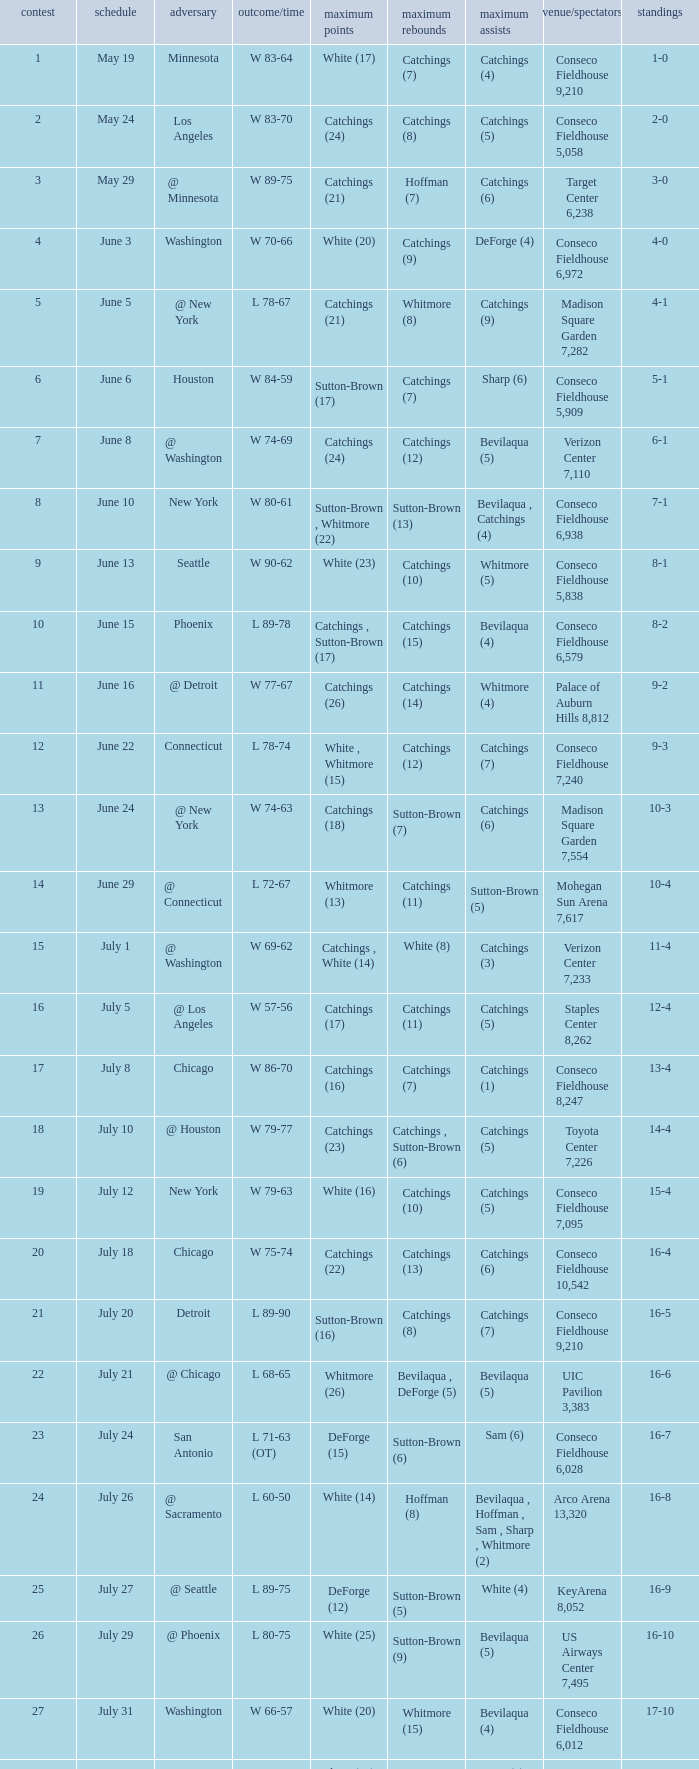Name the total number of opponent of record 9-2 1.0. Write the full table. {'header': ['contest', 'schedule', 'adversary', 'outcome/time', 'maximum points', 'maximum rebounds', 'maximum assists', 'venue/spectators', 'standings'], 'rows': [['1', 'May 19', 'Minnesota', 'W 83-64', 'White (17)', 'Catchings (7)', 'Catchings (4)', 'Conseco Fieldhouse 9,210', '1-0'], ['2', 'May 24', 'Los Angeles', 'W 83-70', 'Catchings (24)', 'Catchings (8)', 'Catchings (5)', 'Conseco Fieldhouse 5,058', '2-0'], ['3', 'May 29', '@ Minnesota', 'W 89-75', 'Catchings (21)', 'Hoffman (7)', 'Catchings (6)', 'Target Center 6,238', '3-0'], ['4', 'June 3', 'Washington', 'W 70-66', 'White (20)', 'Catchings (9)', 'DeForge (4)', 'Conseco Fieldhouse 6,972', '4-0'], ['5', 'June 5', '@ New York', 'L 78-67', 'Catchings (21)', 'Whitmore (8)', 'Catchings (9)', 'Madison Square Garden 7,282', '4-1'], ['6', 'June 6', 'Houston', 'W 84-59', 'Sutton-Brown (17)', 'Catchings (7)', 'Sharp (6)', 'Conseco Fieldhouse 5,909', '5-1'], ['7', 'June 8', '@ Washington', 'W 74-69', 'Catchings (24)', 'Catchings (12)', 'Bevilaqua (5)', 'Verizon Center 7,110', '6-1'], ['8', 'June 10', 'New York', 'W 80-61', 'Sutton-Brown , Whitmore (22)', 'Sutton-Brown (13)', 'Bevilaqua , Catchings (4)', 'Conseco Fieldhouse 6,938', '7-1'], ['9', 'June 13', 'Seattle', 'W 90-62', 'White (23)', 'Catchings (10)', 'Whitmore (5)', 'Conseco Fieldhouse 5,838', '8-1'], ['10', 'June 15', 'Phoenix', 'L 89-78', 'Catchings , Sutton-Brown (17)', 'Catchings (15)', 'Bevilaqua (4)', 'Conseco Fieldhouse 6,579', '8-2'], ['11', 'June 16', '@ Detroit', 'W 77-67', 'Catchings (26)', 'Catchings (14)', 'Whitmore (4)', 'Palace of Auburn Hills 8,812', '9-2'], ['12', 'June 22', 'Connecticut', 'L 78-74', 'White , Whitmore (15)', 'Catchings (12)', 'Catchings (7)', 'Conseco Fieldhouse 7,240', '9-3'], ['13', 'June 24', '@ New York', 'W 74-63', 'Catchings (18)', 'Sutton-Brown (7)', 'Catchings (6)', 'Madison Square Garden 7,554', '10-3'], ['14', 'June 29', '@ Connecticut', 'L 72-67', 'Whitmore (13)', 'Catchings (11)', 'Sutton-Brown (5)', 'Mohegan Sun Arena 7,617', '10-4'], ['15', 'July 1', '@ Washington', 'W 69-62', 'Catchings , White (14)', 'White (8)', 'Catchings (3)', 'Verizon Center 7,233', '11-4'], ['16', 'July 5', '@ Los Angeles', 'W 57-56', 'Catchings (17)', 'Catchings (11)', 'Catchings (5)', 'Staples Center 8,262', '12-4'], ['17', 'July 8', 'Chicago', 'W 86-70', 'Catchings (16)', 'Catchings (7)', 'Catchings (1)', 'Conseco Fieldhouse 8,247', '13-4'], ['18', 'July 10', '@ Houston', 'W 79-77', 'Catchings (23)', 'Catchings , Sutton-Brown (6)', 'Catchings (5)', 'Toyota Center 7,226', '14-4'], ['19', 'July 12', 'New York', 'W 79-63', 'White (16)', 'Catchings (10)', 'Catchings (5)', 'Conseco Fieldhouse 7,095', '15-4'], ['20', 'July 18', 'Chicago', 'W 75-74', 'Catchings (22)', 'Catchings (13)', 'Catchings (6)', 'Conseco Fieldhouse 10,542', '16-4'], ['21', 'July 20', 'Detroit', 'L 89-90', 'Sutton-Brown (16)', 'Catchings (8)', 'Catchings (7)', 'Conseco Fieldhouse 9,210', '16-5'], ['22', 'July 21', '@ Chicago', 'L 68-65', 'Whitmore (26)', 'Bevilaqua , DeForge (5)', 'Bevilaqua (5)', 'UIC Pavilion 3,383', '16-6'], ['23', 'July 24', 'San Antonio', 'L 71-63 (OT)', 'DeForge (15)', 'Sutton-Brown (6)', 'Sam (6)', 'Conseco Fieldhouse 6,028', '16-7'], ['24', 'July 26', '@ Sacramento', 'L 60-50', 'White (14)', 'Hoffman (8)', 'Bevilaqua , Hoffman , Sam , Sharp , Whitmore (2)', 'Arco Arena 13,320', '16-8'], ['25', 'July 27', '@ Seattle', 'L 89-75', 'DeForge (12)', 'Sutton-Brown (5)', 'White (4)', 'KeyArena 8,052', '16-9'], ['26', 'July 29', '@ Phoenix', 'L 80-75', 'White (25)', 'Sutton-Brown (9)', 'Bevilaqua (5)', 'US Airways Center 7,495', '16-10'], ['27', 'July 31', 'Washington', 'W 66-57', 'White (20)', 'Whitmore (15)', 'Bevilaqua (4)', 'Conseco Fieldhouse 6,012', '17-10'], ['28', 'August 4', '@ Connecticut', 'L 84-59', 'Sharp (14)', 'Sutton-Brown (8)', 'Sam (4)', 'Mohegan Sun Arena 9,493', '17-11'], ['29', 'August 5', 'Sacramento', 'W 63-55', 'Whitmore (16)', 'Hoffman , Sutton-Brown , White (6)', 'Bevilaqua , DeForge (4)', 'Conseco Fieldhouse 6,645', '18-11'], ['30', 'August 7', '@ Chicago', 'W 75-70 (2OT)', 'DeForge (16)', 'DeForge (9)', 'White (5)', 'UIC Pavilion 5,029', '19-11'], ['31', 'August 11', '@ Detroit', 'L 74-69', 'White (15)', 'DeForge (7)', 'White (4)', 'Palace of Auburn Hills 10,857', '19-12'], ['32', 'August 15', 'Connecticut', 'L 77-74', 'DeForge (29)', 'Sutton-Brown (10)', 'White (4)', 'Conseco Fieldhouse 6,433', '19-13'], ['33', 'August 17', '@ San Antonio', 'W 59-55', 'Whitmore (12)', 'Sam (7)', 'Sharp (3)', 'AT&T Center 8,952', '20-13']]} 